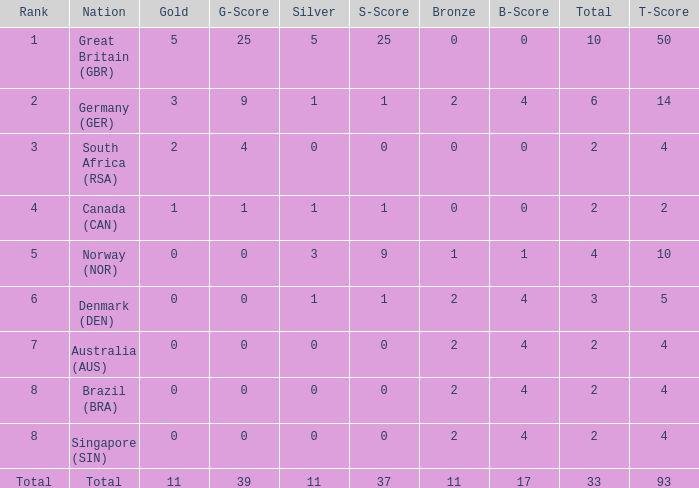What is the total when the nation is brazil (bra) and bronze is more than 2? None. 